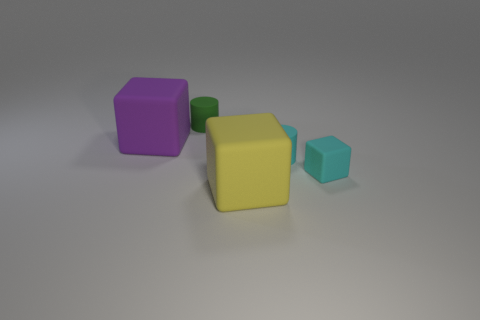The rubber object that is the same color as the tiny cube is what shape?
Offer a very short reply. Cylinder. Does the rubber cylinder to the right of the yellow matte thing have the same size as the cube that is on the left side of the big yellow cube?
Your response must be concise. No. There is a matte thing on the left side of the green cylinder; how big is it?
Offer a very short reply. Large. There is a object that is the same color as the tiny cube; what is its material?
Your response must be concise. Rubber. What color is the rubber block that is the same size as the purple object?
Your answer should be compact. Yellow. Does the green matte cylinder have the same size as the purple matte block?
Keep it short and to the point. No. How big is the thing that is right of the large purple cube and to the left of the yellow matte object?
Provide a short and direct response. Small. How many metallic objects are large cubes or large gray things?
Your answer should be very brief. 0. Is the number of big matte blocks right of the small green cylinder greater than the number of yellow matte balls?
Offer a terse response. Yes. What is the material of the cyan thing left of the tiny cyan rubber cube?
Ensure brevity in your answer.  Rubber. 